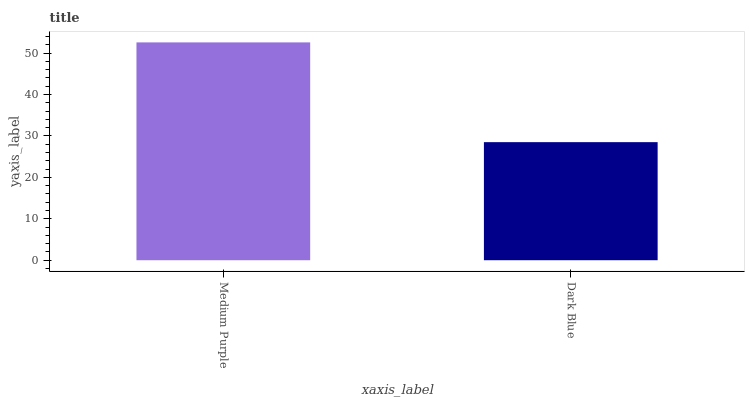Is Dark Blue the minimum?
Answer yes or no. Yes. Is Medium Purple the maximum?
Answer yes or no. Yes. Is Dark Blue the maximum?
Answer yes or no. No. Is Medium Purple greater than Dark Blue?
Answer yes or no. Yes. Is Dark Blue less than Medium Purple?
Answer yes or no. Yes. Is Dark Blue greater than Medium Purple?
Answer yes or no. No. Is Medium Purple less than Dark Blue?
Answer yes or no. No. Is Medium Purple the high median?
Answer yes or no. Yes. Is Dark Blue the low median?
Answer yes or no. Yes. Is Dark Blue the high median?
Answer yes or no. No. Is Medium Purple the low median?
Answer yes or no. No. 